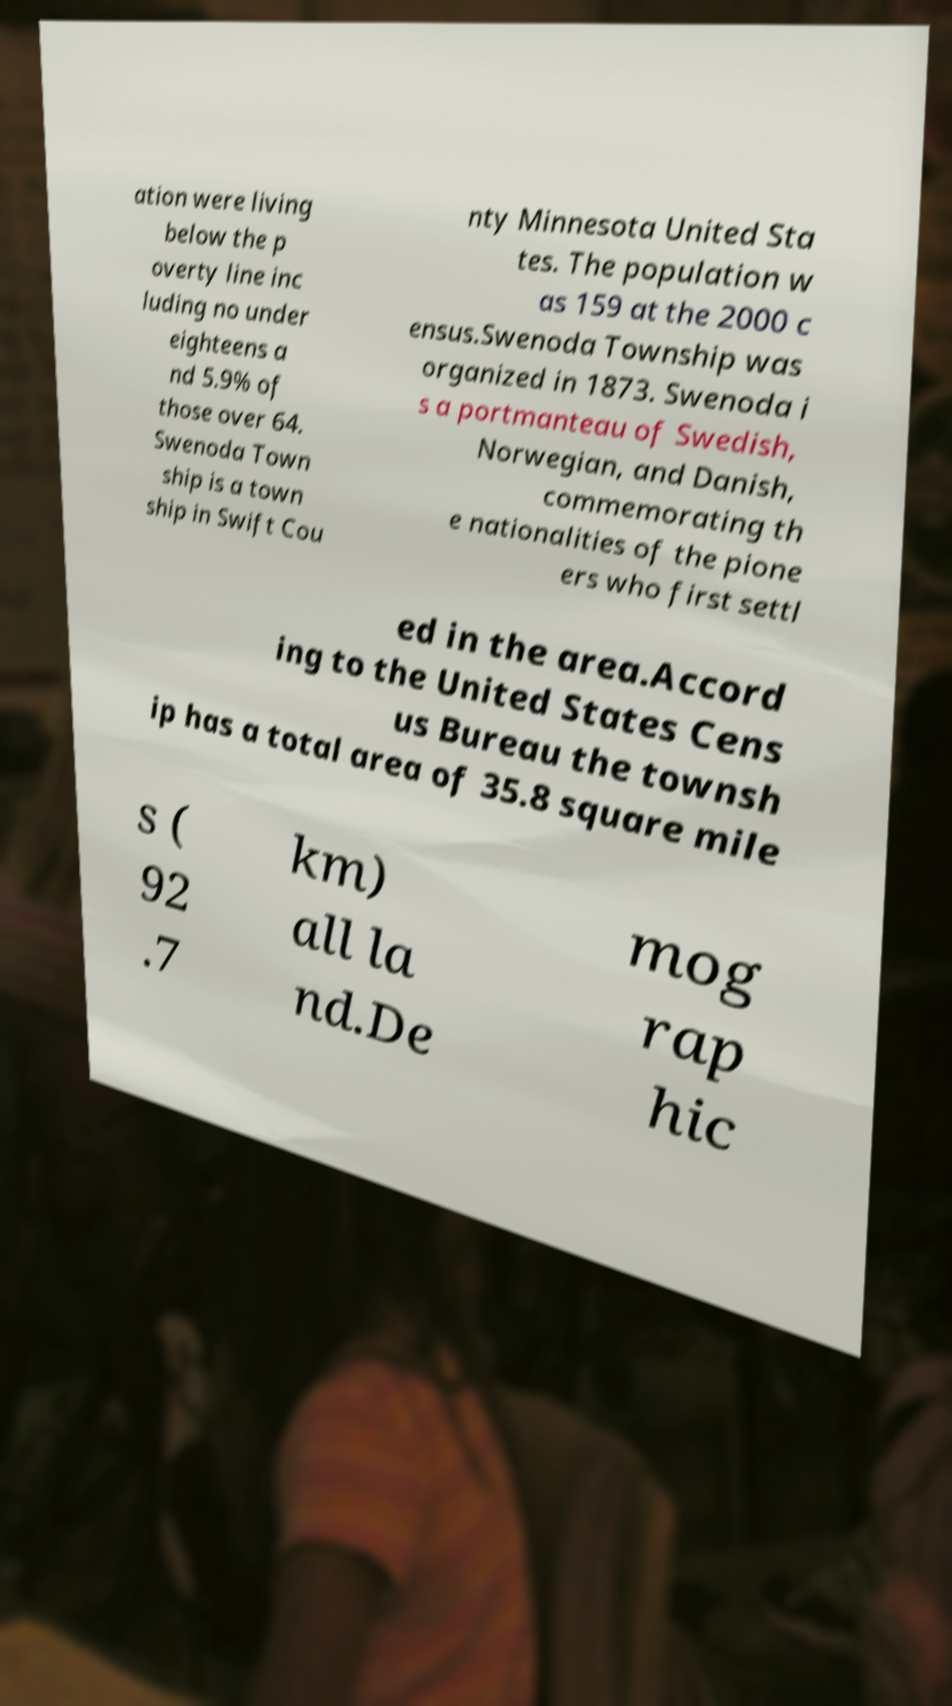Could you assist in decoding the text presented in this image and type it out clearly? ation were living below the p overty line inc luding no under eighteens a nd 5.9% of those over 64. Swenoda Town ship is a town ship in Swift Cou nty Minnesota United Sta tes. The population w as 159 at the 2000 c ensus.Swenoda Township was organized in 1873. Swenoda i s a portmanteau of Swedish, Norwegian, and Danish, commemorating th e nationalities of the pione ers who first settl ed in the area.Accord ing to the United States Cens us Bureau the townsh ip has a total area of 35.8 square mile s ( 92 .7 km) all la nd.De mog rap hic 